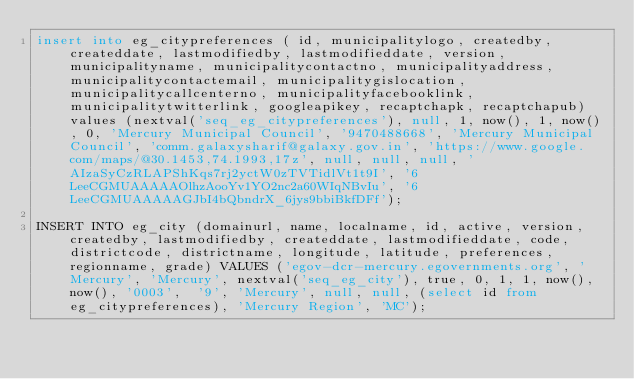<code> <loc_0><loc_0><loc_500><loc_500><_SQL_>insert into eg_citypreferences ( id, municipalitylogo, createdby, createddate, lastmodifiedby, lastmodifieddate, version, municipalityname, municipalitycontactno, municipalityaddress, municipalitycontactemail, municipalitygislocation, municipalitycallcenterno, municipalityfacebooklink, municipalitytwitterlink, googleapikey, recaptchapk, recaptchapub) values (nextval('seq_eg_citypreferences'), null, 1, now(), 1, now(), 0, 'Mercury Municipal Council', '9470488668', 'Mercury Municipal Council', 'comm.galaxysharif@galaxy.gov.in', 'https://www.google.com/maps/@30.1453,74.1993,17z', null, null, null, 'AIzaSyCzRLAPShKqs7rj2yctW0zTVTidlVt1t9I', '6LeeCGMUAAAAAOlhzAooYv1YO2nc2a60WIqNBvIu', '6LeeCGMUAAAAAGJbI4bQbndrX_6jys9bbiBkfDFf');

INSERT INTO eg_city (domainurl, name, localname, id, active, version, createdby, lastmodifiedby, createddate, lastmodifieddate, code,  districtcode, districtname, longitude, latitude, preferences, regionname, grade) VALUES ('egov-dcr-mercury.egovernments.org', 'Mercury', 'Mercury', nextval('seq_eg_city'), true, 0, 1, 1, now(), now(), '0003',  '9', 'Mercury', null, null, (select id from eg_citypreferences), 'Mercury Region', 'MC');</code> 